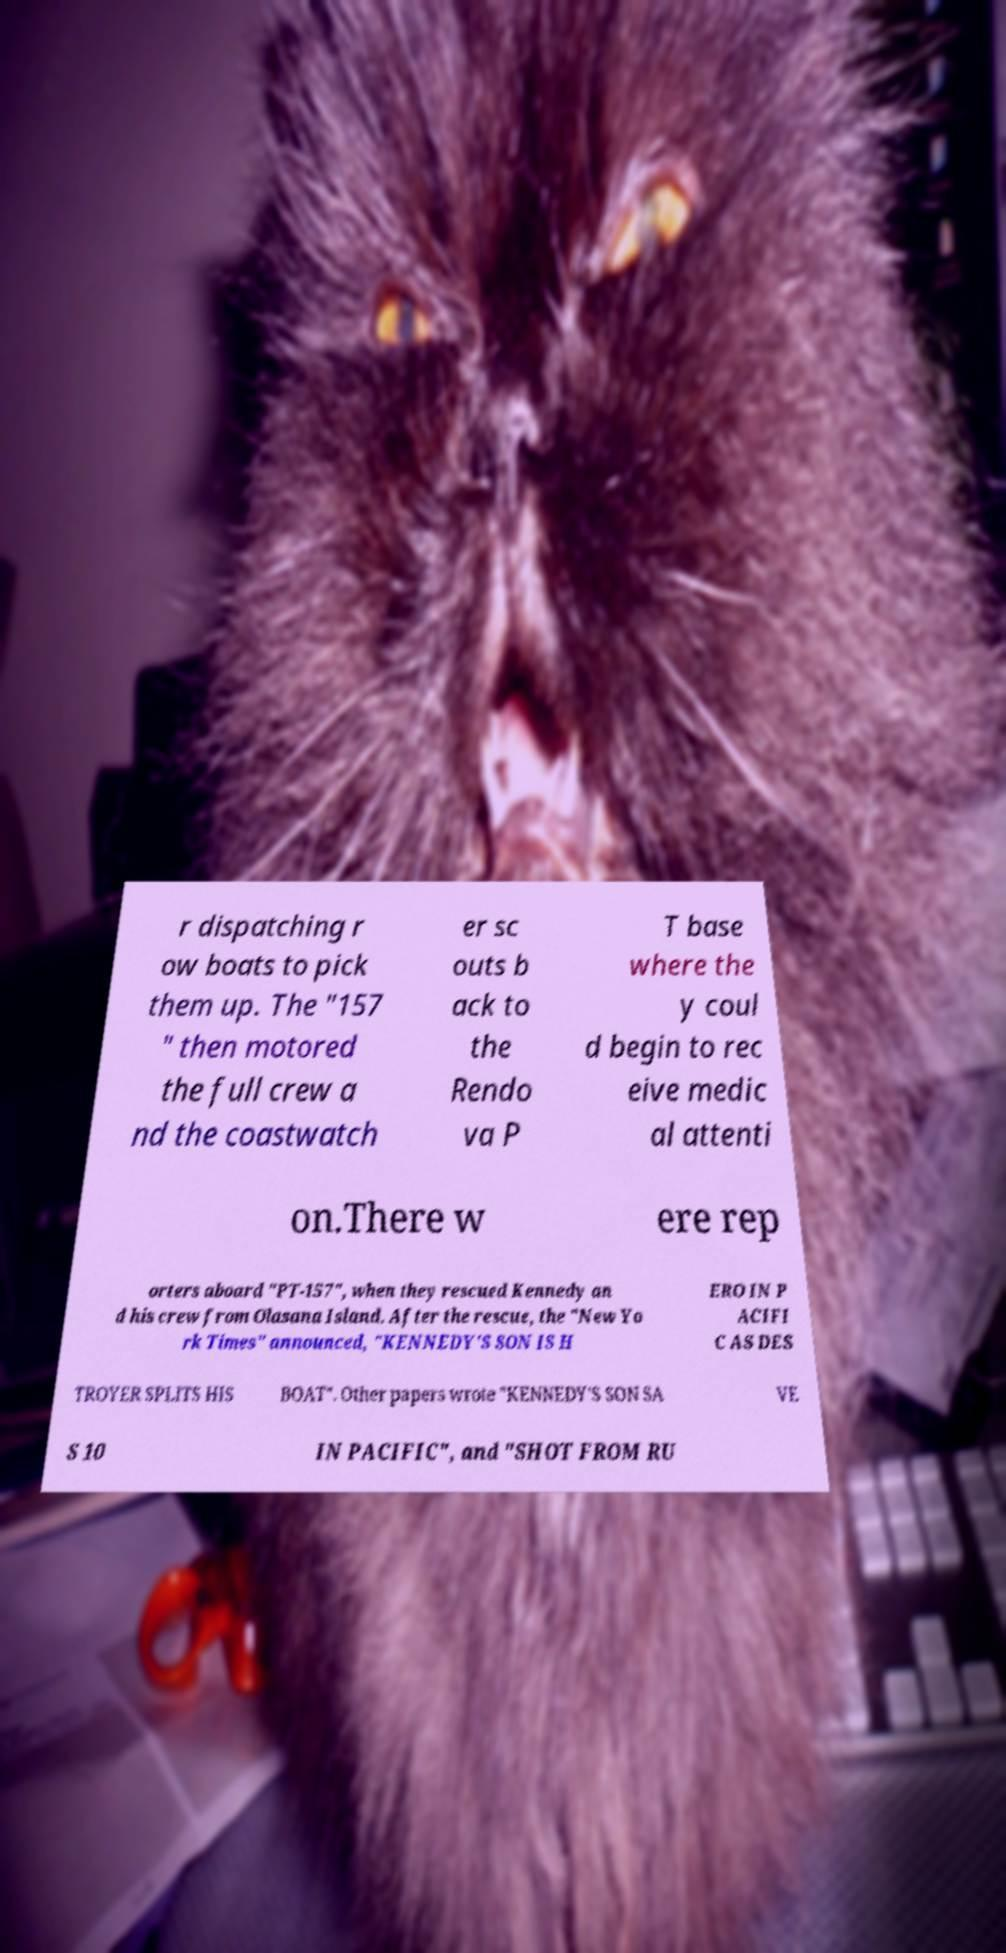Can you accurately transcribe the text from the provided image for me? r dispatching r ow boats to pick them up. The "157 " then motored the full crew a nd the coastwatch er sc outs b ack to the Rendo va P T base where the y coul d begin to rec eive medic al attenti on.There w ere rep orters aboard "PT-157", when they rescued Kennedy an d his crew from Olasana Island. After the rescue, the "New Yo rk Times" announced, "KENNEDY'S SON IS H ERO IN P ACIFI C AS DES TROYER SPLITS HIS BOAT". Other papers wrote "KENNEDY'S SON SA VE S 10 IN PACIFIC", and "SHOT FROM RU 